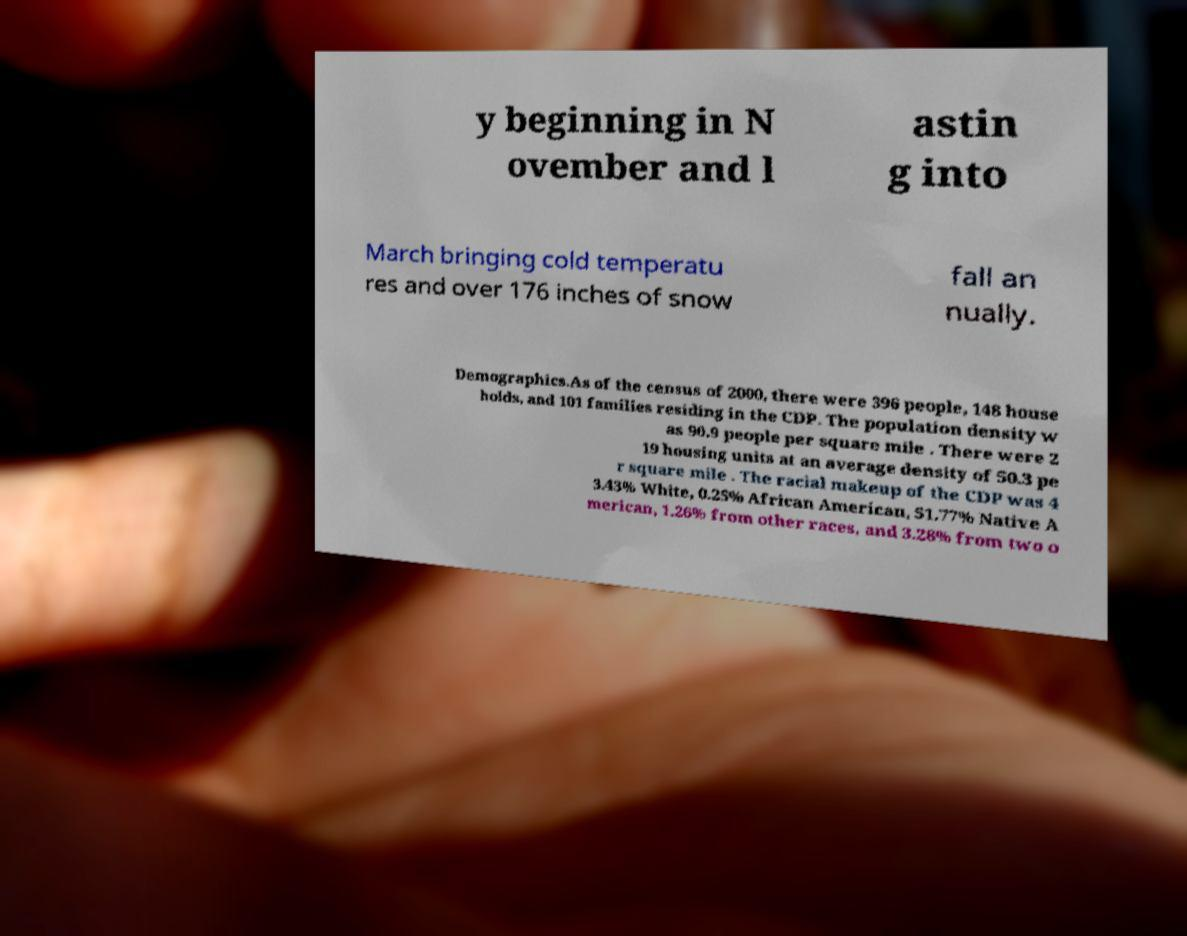Can you accurately transcribe the text from the provided image for me? y beginning in N ovember and l astin g into March bringing cold temperatu res and over 176 inches of snow fall an nually. Demographics.As of the census of 2000, there were 396 people, 148 house holds, and 101 families residing in the CDP. The population density w as 90.9 people per square mile . There were 2 19 housing units at an average density of 50.3 pe r square mile . The racial makeup of the CDP was 4 3.43% White, 0.25% African American, 51.77% Native A merican, 1.26% from other races, and 3.28% from two o 